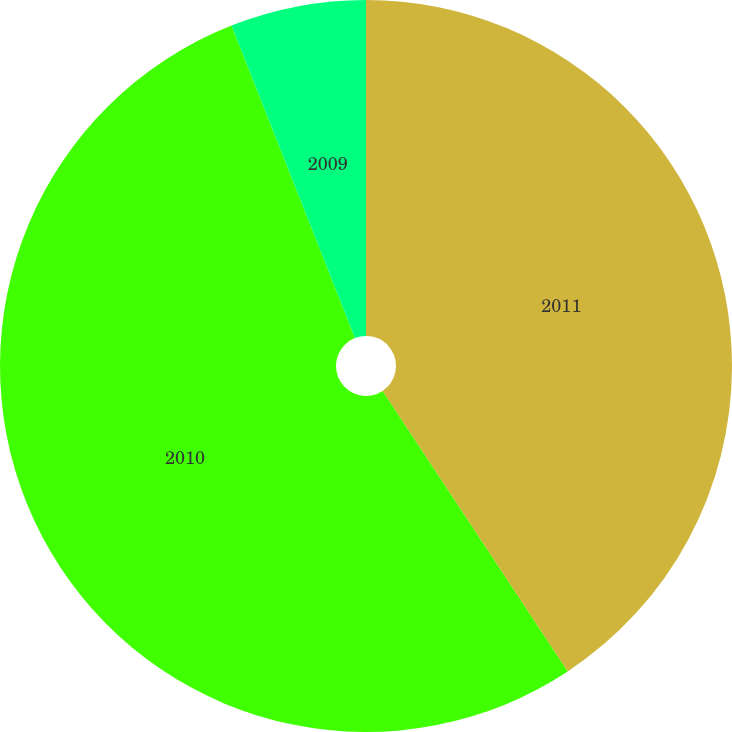<chart> <loc_0><loc_0><loc_500><loc_500><pie_chart><fcel>2011<fcel>2010<fcel>2009<nl><fcel>40.71%<fcel>53.3%<fcel>5.99%<nl></chart> 